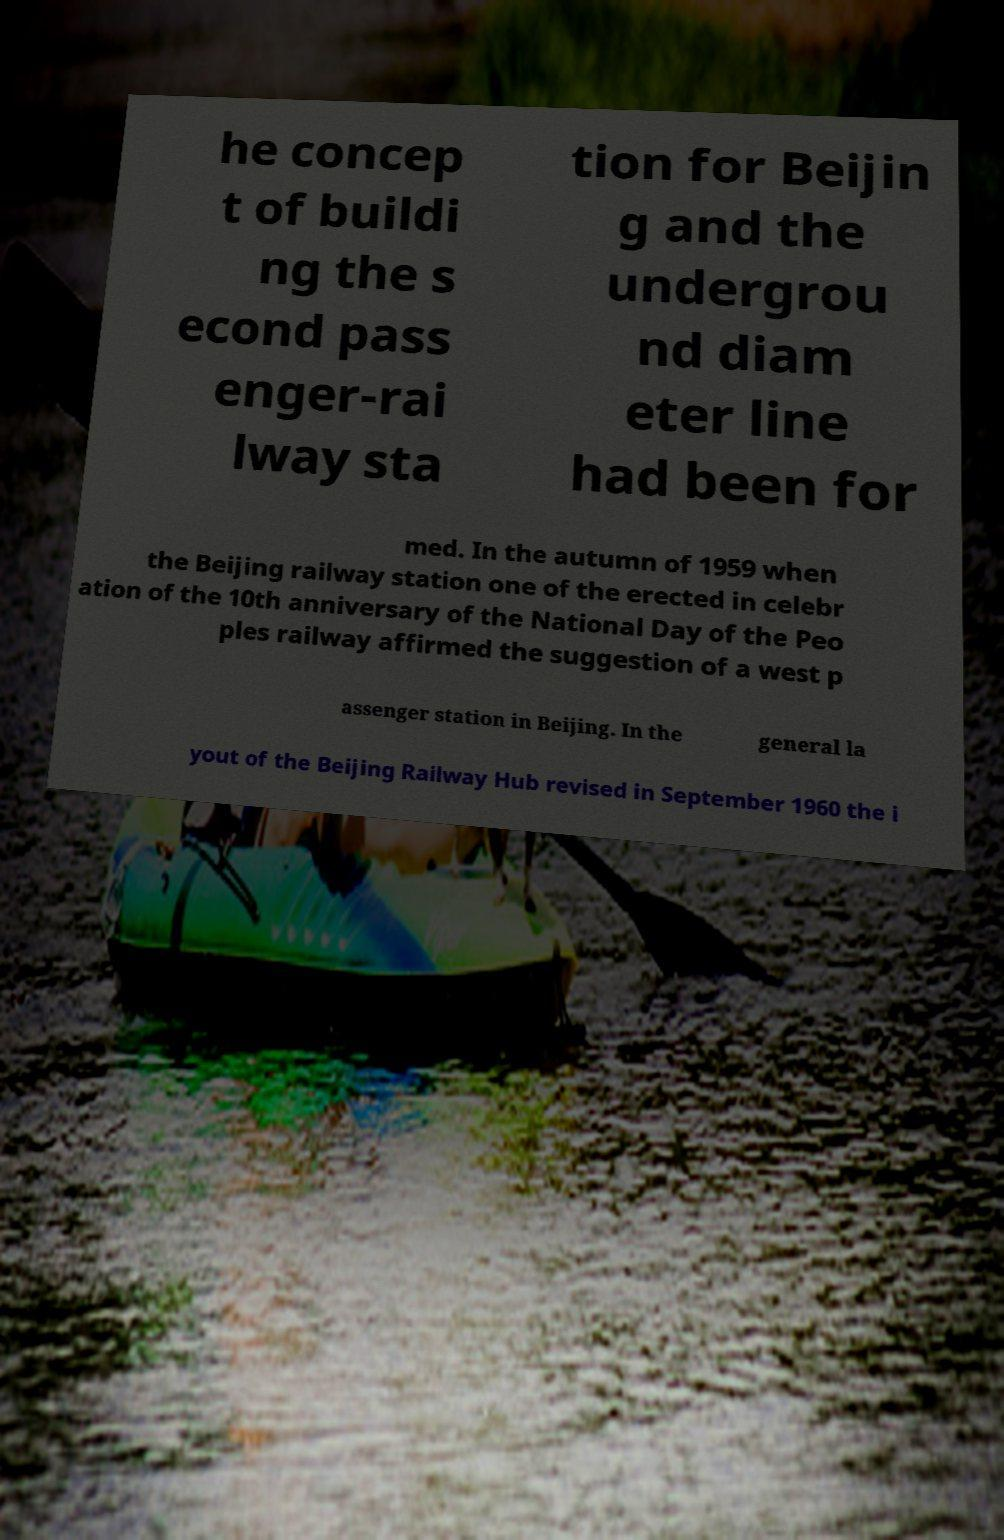Please read and relay the text visible in this image. What does it say? he concep t of buildi ng the s econd pass enger-rai lway sta tion for Beijin g and the undergrou nd diam eter line had been for med. In the autumn of 1959 when the Beijing railway station one of the erected in celebr ation of the 10th anniversary of the National Day of the Peo ples railway affirmed the suggestion of a west p assenger station in Beijing. In the general la yout of the Beijing Railway Hub revised in September 1960 the i 